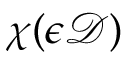<formula> <loc_0><loc_0><loc_500><loc_500>\chi ( \epsilon \mathcal { D } )</formula> 